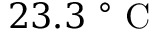<formula> <loc_0><loc_0><loc_500><loc_500>2 3 . 3 ^ { \circ } C</formula> 